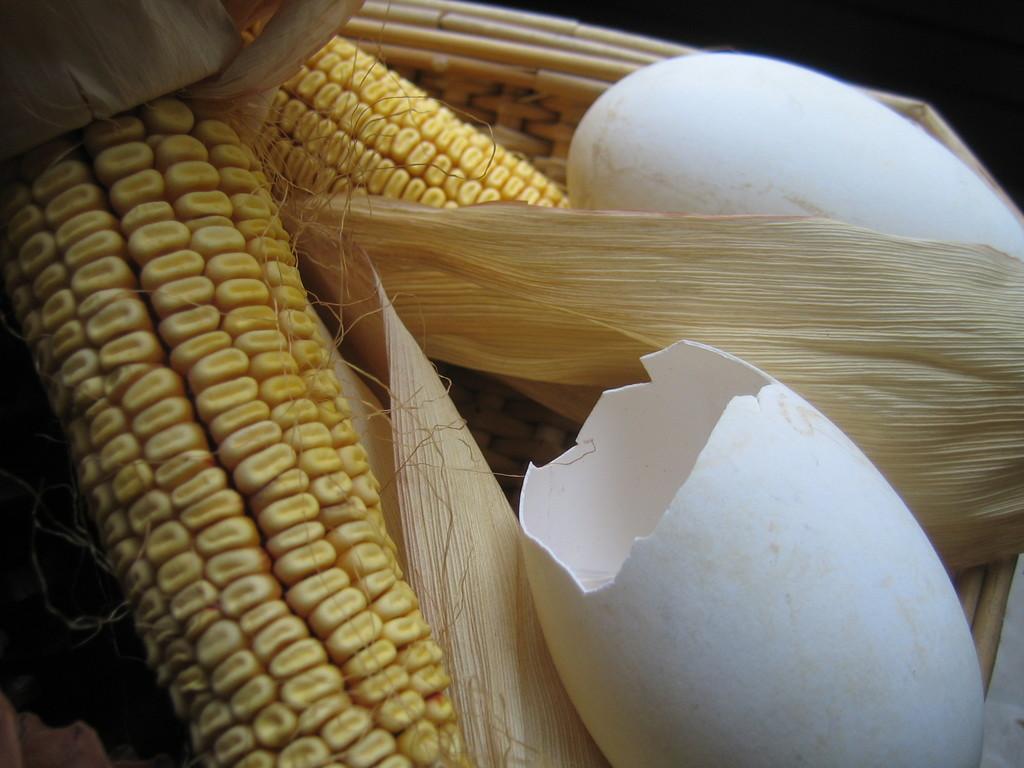Could you give a brief overview of what you see in this image? In this image we can see the maize and the shells of the eggs in a basket. 